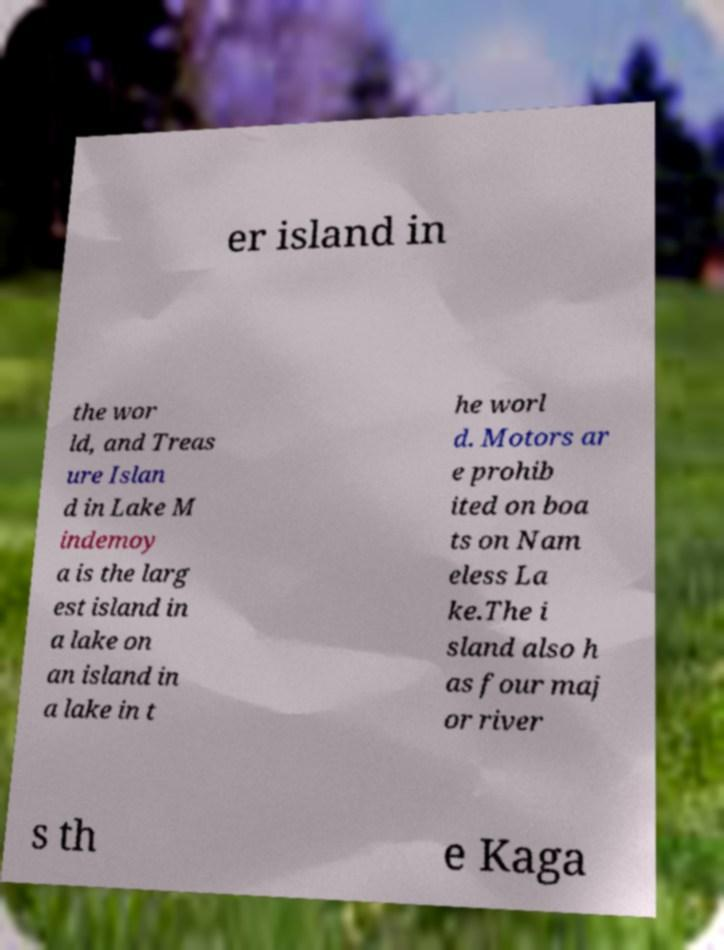Can you read and provide the text displayed in the image?This photo seems to have some interesting text. Can you extract and type it out for me? er island in the wor ld, and Treas ure Islan d in Lake M indemoy a is the larg est island in a lake on an island in a lake in t he worl d. Motors ar e prohib ited on boa ts on Nam eless La ke.The i sland also h as four maj or river s th e Kaga 